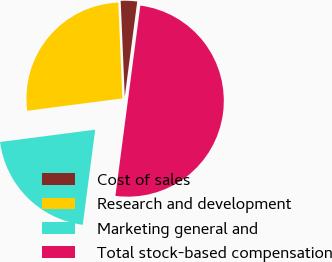Convert chart to OTSL. <chart><loc_0><loc_0><loc_500><loc_500><pie_chart><fcel>Cost of sales<fcel>Research and development<fcel>Marketing general and<fcel>Total stock-based compensation<nl><fcel>2.75%<fcel>26.37%<fcel>20.88%<fcel>50.0%<nl></chart> 